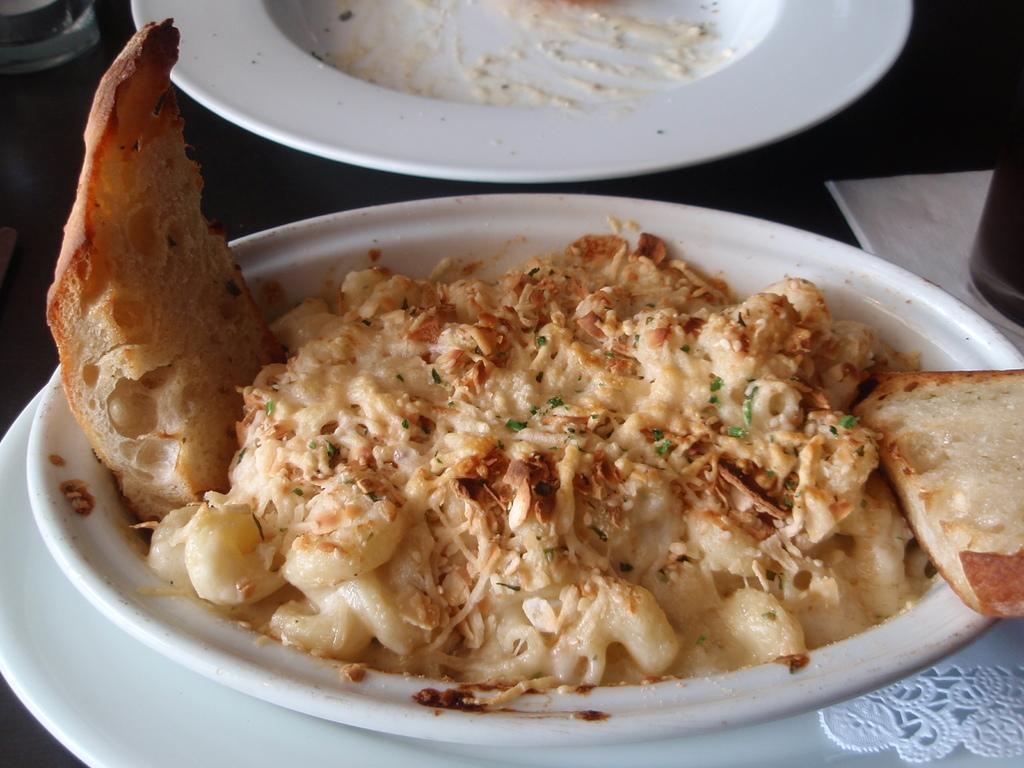In one or two sentences, can you explain what this image depicts? In this image there is a table. There are plates. There are food items. There is a glass. There is tissue. 